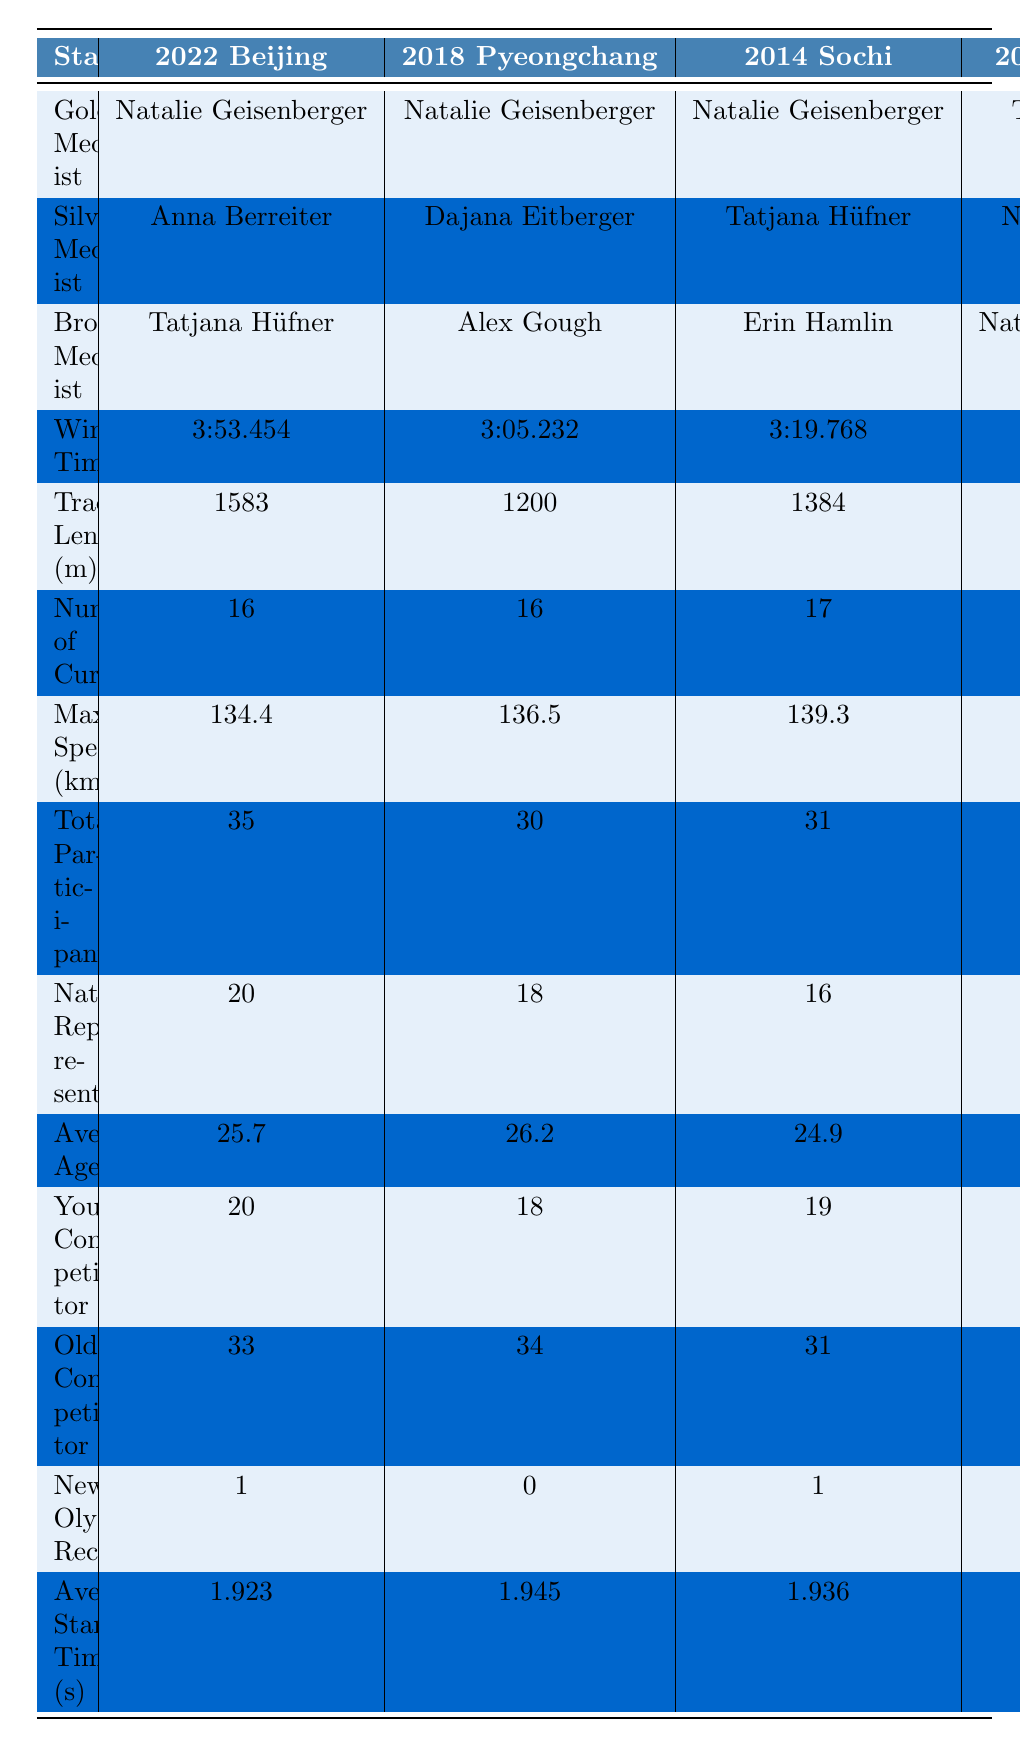What is the maximum speed recorded in the 2010 Vancouver games? According to the table, the maximum speed recorded in the 2010 Vancouver games is 145.7 km/h.
Answer: 145.7 km/h Who won the silver medal in the 2022 Beijing games? The silver medalist in the 2022 Beijing games is Anna Berreiter, as listed in the table.
Answer: Anna Berreiter Which year had the highest number of total participants? By comparing the values, the highest number of total participants is 35 in the 2022 Beijing games, as noted in the table.
Answer: 35 How many Olympic records were set in total during the last five Winter Games? By summing the new Olympic records, we find: 1 (2022) + 0 (2018) + 1 (2014) + 1 (2010) + 0 (2006) = 3.
Answer: 3 Which Olympic games had the longest track length? The longest track length is 1583 meters, which occurred in the 2022 Beijing games, as shown in the table.
Answer: 1583 meters Was the youngest competitor in the 2022 games older than 18? The youngest competitor in the 2022 games was 20 years old, which is older than 18. Therefore, the answer is yes.
Answer: Yes Calculate the average age of competitors across the five games. To find the average, we sum the ages: (25.7 + 26.2 + 24.9 + 25.5 + 26.8) = 129.1, and then divide by 5, giving an average age of 25.82 years.
Answer: 25.82 Which year had the fewest nations represented? Upon reviewing, the 2006 Turin games had the fewest nations represented at 14, making it the answer.
Answer: 14 Did any of the years set a new Olympic record for maximum speed? By analyzing the data, none of the years listed show a new Olympic record for maximum speed, so the answer is no.
Answer: No What was the difference in average start times between the 2022 and 2006 games? The average start time for 2022 is 1.923 seconds and for 2006 is 1.967 seconds. The difference is 1.967 - 1.923 = 0.044 seconds.
Answer: 0.044 seconds 